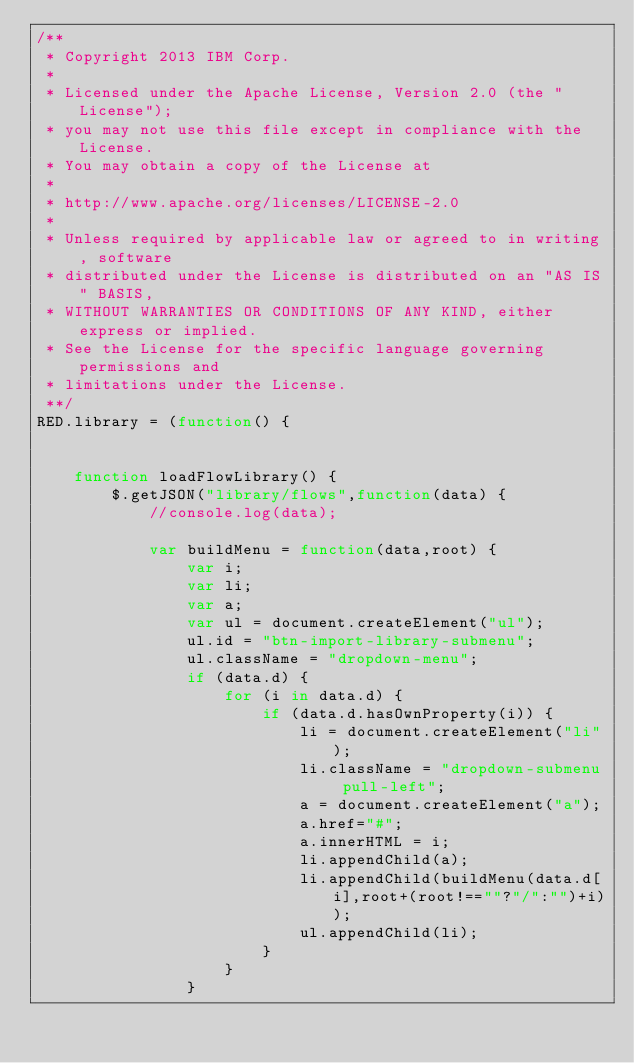<code> <loc_0><loc_0><loc_500><loc_500><_JavaScript_>/**
 * Copyright 2013 IBM Corp.
 *
 * Licensed under the Apache License, Version 2.0 (the "License");
 * you may not use this file except in compliance with the License.
 * You may obtain a copy of the License at
 *
 * http://www.apache.org/licenses/LICENSE-2.0
 *
 * Unless required by applicable law or agreed to in writing, software
 * distributed under the License is distributed on an "AS IS" BASIS,
 * WITHOUT WARRANTIES OR CONDITIONS OF ANY KIND, either express or implied.
 * See the License for the specific language governing permissions and
 * limitations under the License.
 **/
RED.library = (function() {
    
    
    function loadFlowLibrary() {
        $.getJSON("library/flows",function(data) {
            //console.log(data);

            var buildMenu = function(data,root) {
                var i;
                var li;
                var a;
                var ul = document.createElement("ul");
                ul.id = "btn-import-library-submenu";
                ul.className = "dropdown-menu";
                if (data.d) {
                    for (i in data.d) {
                        if (data.d.hasOwnProperty(i)) {
                            li = document.createElement("li");
                            li.className = "dropdown-submenu pull-left";
                            a = document.createElement("a");
                            a.href="#";
                            a.innerHTML = i;
                            li.appendChild(a);
                            li.appendChild(buildMenu(data.d[i],root+(root!==""?"/":"")+i));
                            ul.appendChild(li);
                        }
                    }
                }</code> 